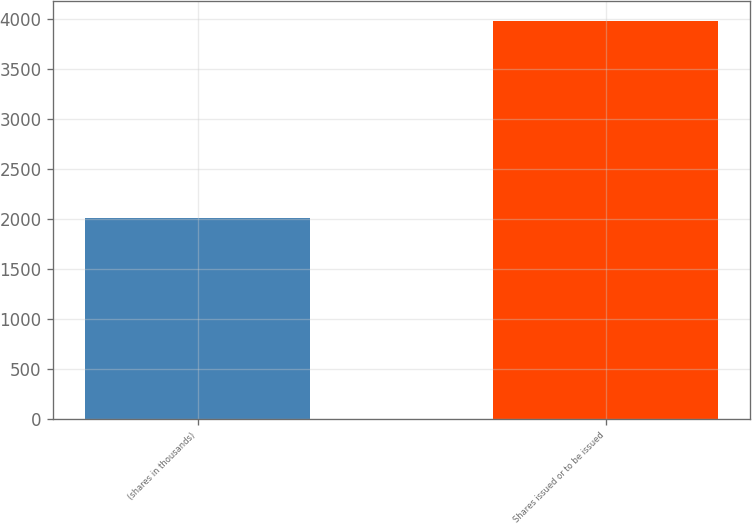Convert chart to OTSL. <chart><loc_0><loc_0><loc_500><loc_500><bar_chart><fcel>(shares in thousands)<fcel>Shares issued or to be issued<nl><fcel>2012<fcel>3979<nl></chart> 